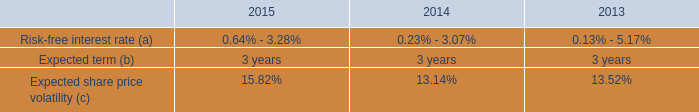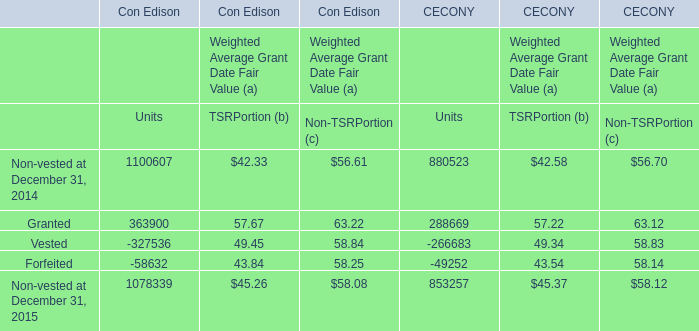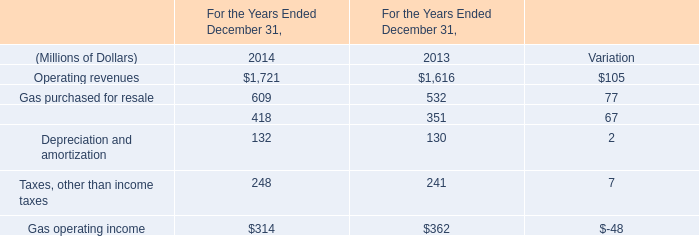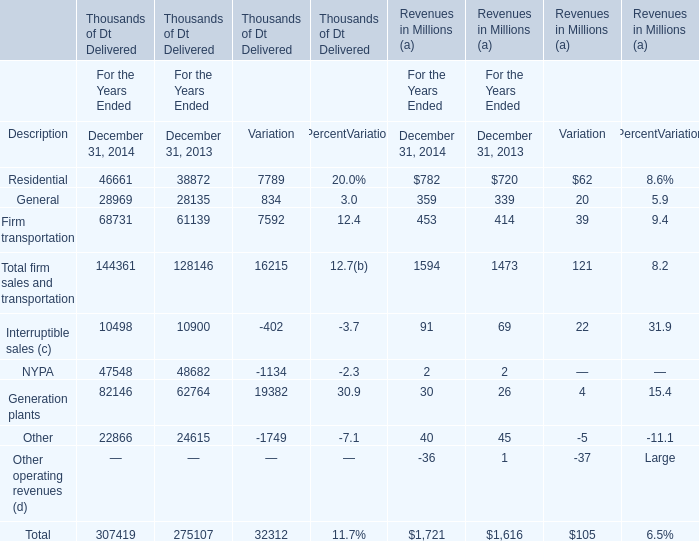What is the sum of Residential,General and Firm transportation in December 31, 2014 for Thousands of Dt Delivered ? (in thousand) 
Computations: ((46661 + 28969) + 68731)
Answer: 144361.0. 